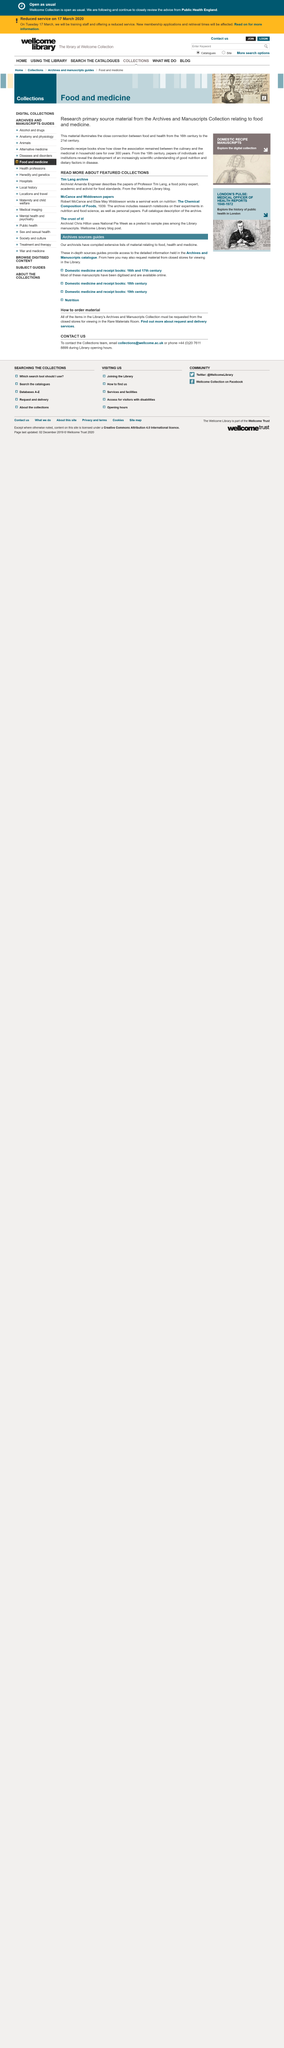Give some essential details in this illustration. The two archivists named in the text are Amanda Engineer and Chris Hilton. Pies are sampled during National Pie Week, which occurs during the week. 